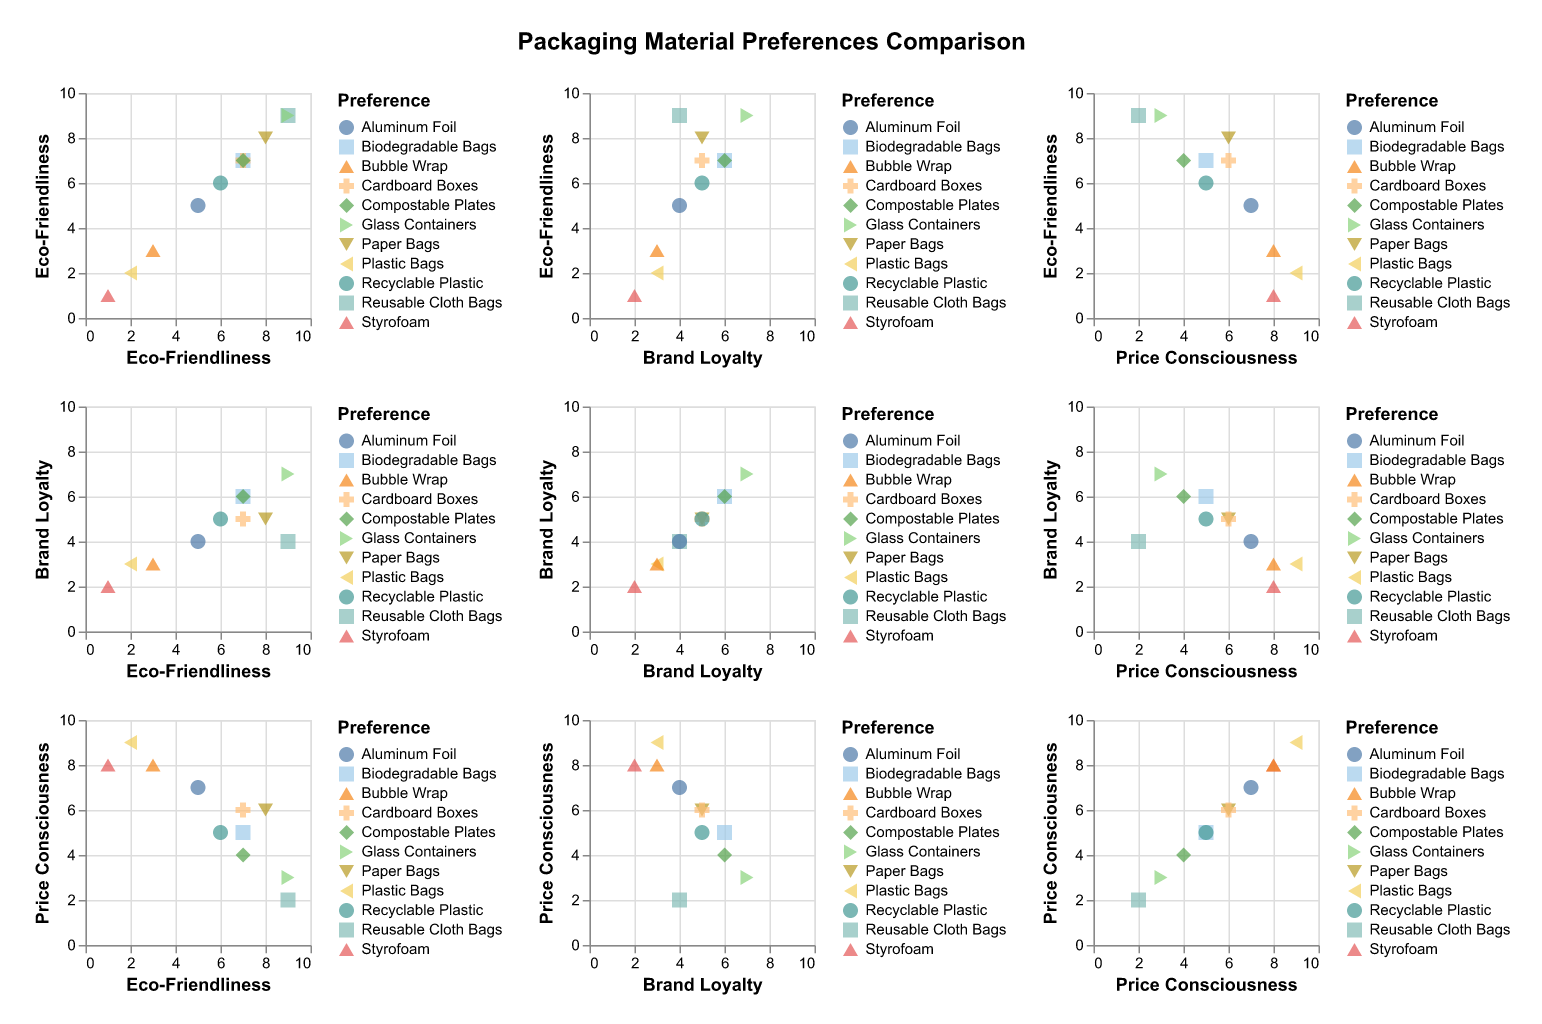What is the title of the figure? The title of the figure is typically displayed prominently at its top. In this figure, it's centered and slightly above the actual scatter plots.
Answer: Packaging Material Preferences Comparison Which packaging preference scores the highest in Eco-Friendliness? Look for the highest value on the Eco-Friendliness axis and identify the corresponding preference. In this plot, "Reusable Cloth Bags" and "Glass Containers" have the highest Eco-Friendliness score, which is 9.
Answer: Reusable Cloth Bags, Glass Containers Which packaging material has the highest Price Consciousness score? Examine the Price Consciousness axis and look for the point at the highest value. The material corresponding to this point is "Plastic Bags" with a score of 9.
Answer: Plastic Bags Among the materials with a Brand Loyalty score of 5, which one has a higher Eco-Friendliness score, Paper Bags or Recyclable Plastic? Locate the points where Brand Loyalty is 5 for both materials. Then compare their positions on the Eco-Friendliness axis; "Paper Bags" has a score of 8 whereas "Recyclable Plastic" has a score of 6.
Answer: Paper Bags Which material shows a strong balance between Eco-Friendliness and Price Consciousness? Look across the scatter plots for points that are relatively high on both the Eco-Friendliness and Price Consciousness axes. "Compostable Plates" shows a good balance with a score of 7 in Eco-Friendliness and 4 in Price Consciousness.
Answer: Compostable Plates Is there a material that has above-average scores in both Brand Loyalty and Eco-Friendliness? Calculate the average scores for Brand Loyalty and Eco-Friendliness, then find the materials that exceed both averages. The averages are (3+5+4+6+4+7+2+5+3+5+6)/11 ≈ 4.64 and (2+8+9+7+5+9+1+7+3+6+7)/11 ≈ 5.64 respectively. Glass Containers and Biodegradable Bags both meet these criteria.
Answer: Glass Containers, Biodegradable Bags Do any materials have an inverse relationship between Eco-Friendliness and Price Consciousness? Look for materials where higher Eco-Friendliness scores correspond to lower Price Consciousness scores and vice versa. "Reusable Cloth Bags" shows this inverse relationship clearly with a high Eco-Friendliness score of 9 and a low Price Consciousness score of 2.
Answer: Reusable Cloth Bags Which two materials have the most similar scores across Eco-Friendliness, Brand Loyalty, and Price Consciousness? Find the materials with very close points in all three plots. "Cardboard Boxes" and "Biodegradable Bags" are very similar with scores of 7, 5, 6 and 7, 6, 5 respectively.
Answer: Cardboard Boxes, Biodegradable Bags What is the spread of Eco-Friendliness scores for materials with a Price Consciousness score of 5? Examine the scatter plots to find points where Price Consciousness is 5 and identify their Eco-Friendliness scores. Biodegradable Bags, Recyclable Plastic, and Compostable Plates have Eco-Friendliness scores of 7, 6, and 7 respectively.
Answer: 6, 7, 7 